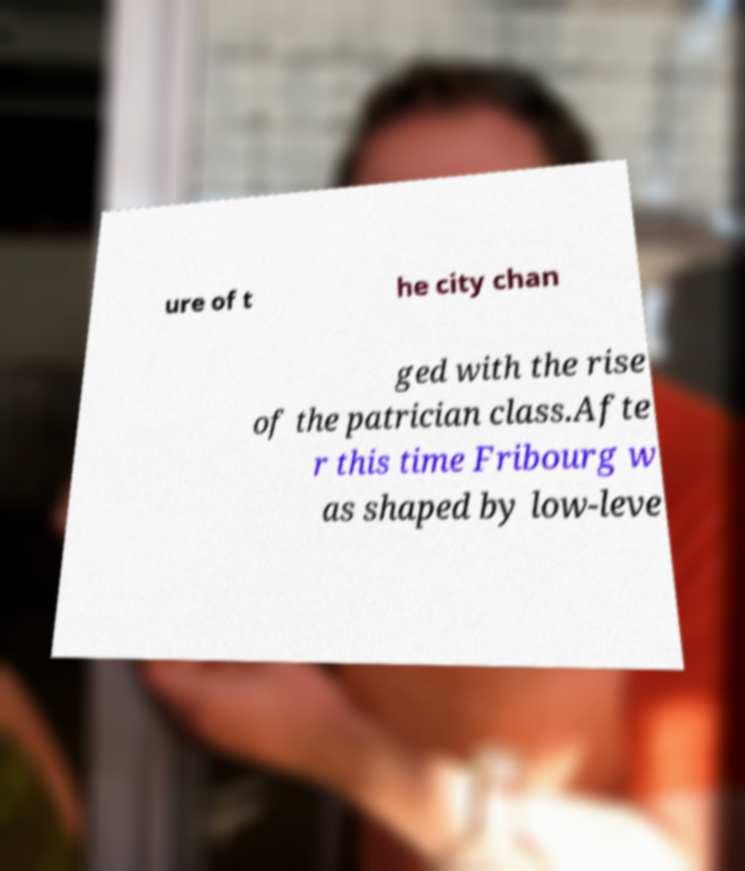What messages or text are displayed in this image? I need them in a readable, typed format. ure of t he city chan ged with the rise of the patrician class.Afte r this time Fribourg w as shaped by low-leve 